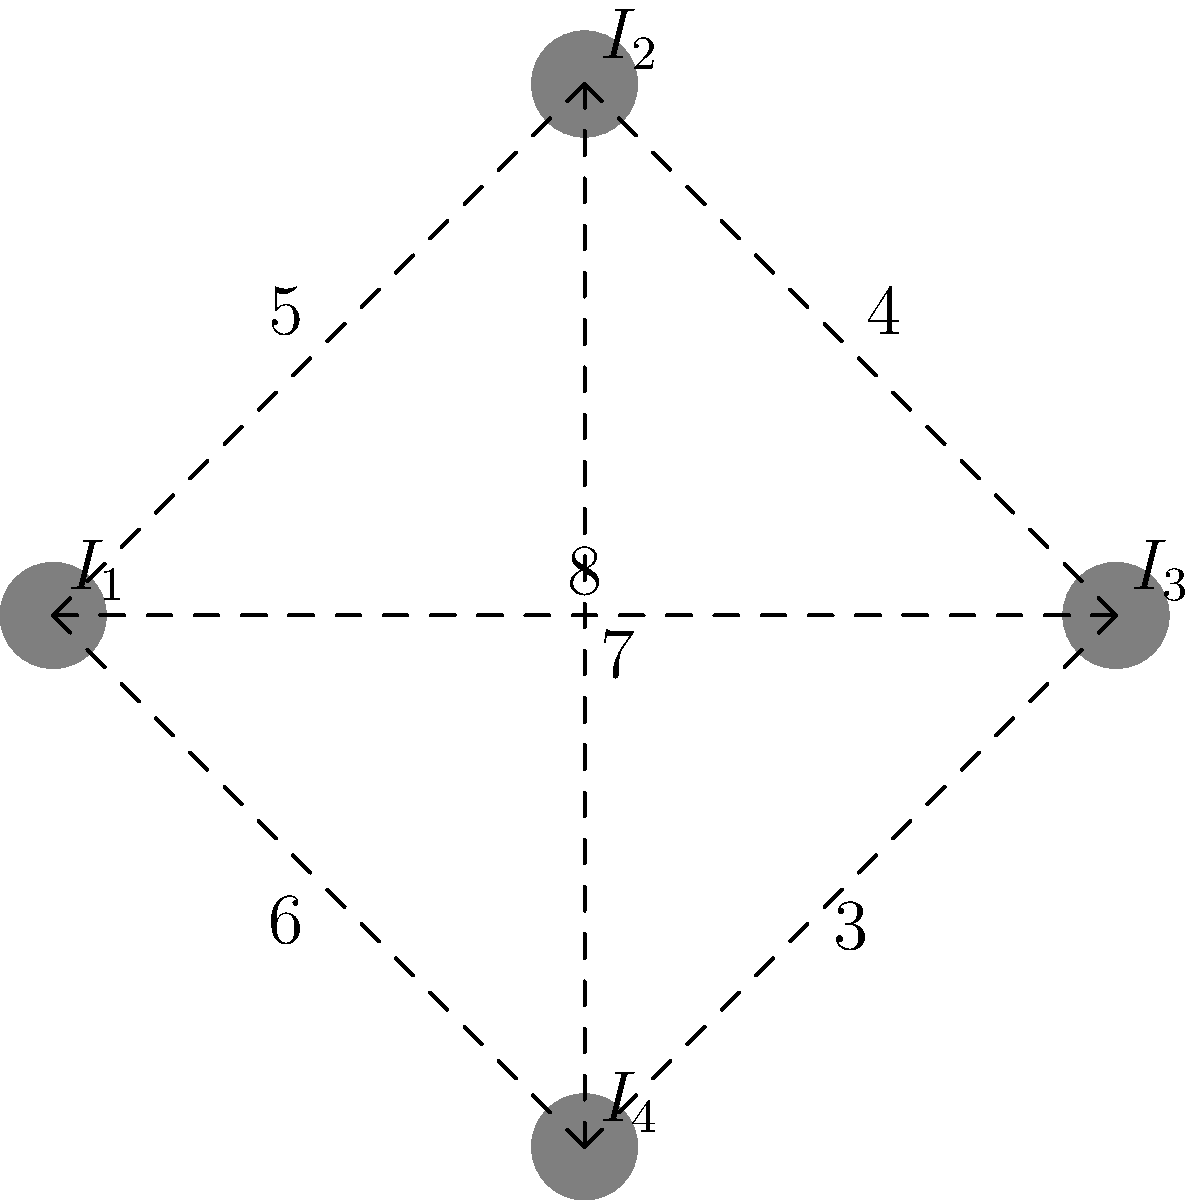In a hypothetical scenario, four islands in Victoria Harbour need to be connected by bridges. The distances between the islands are shown in the diagram (in kilometers). What is the minimum total length of bridges required to connect all four islands? To solve this problem, we need to find the minimum spanning tree of the graph. Here's how we can approach it:

1. List all possible connections and their lengths:
   $I_1 - I_2$: 5 km
   $I_1 - I_3$: 8 km
   $I_1 - I_4$: 6 km
   $I_2 - I_3$: 4 km
   $I_2 - I_4$: 7 km
   $I_3 - I_4$: 3 km

2. Start with the shortest connection:
   $I_3 - I_4$: 3 km

3. Find the next shortest connection that doesn't create a cycle:
   $I_2 - I_3$: 4 km

4. Find the final connection to include all islands:
   $I_1 - I_2$: 5 km

5. Sum up the lengths of the chosen connections:
   $3 + 4 + 5 = 12$ km

Therefore, the minimum total length of bridges required is 12 km.
Answer: 12 km 